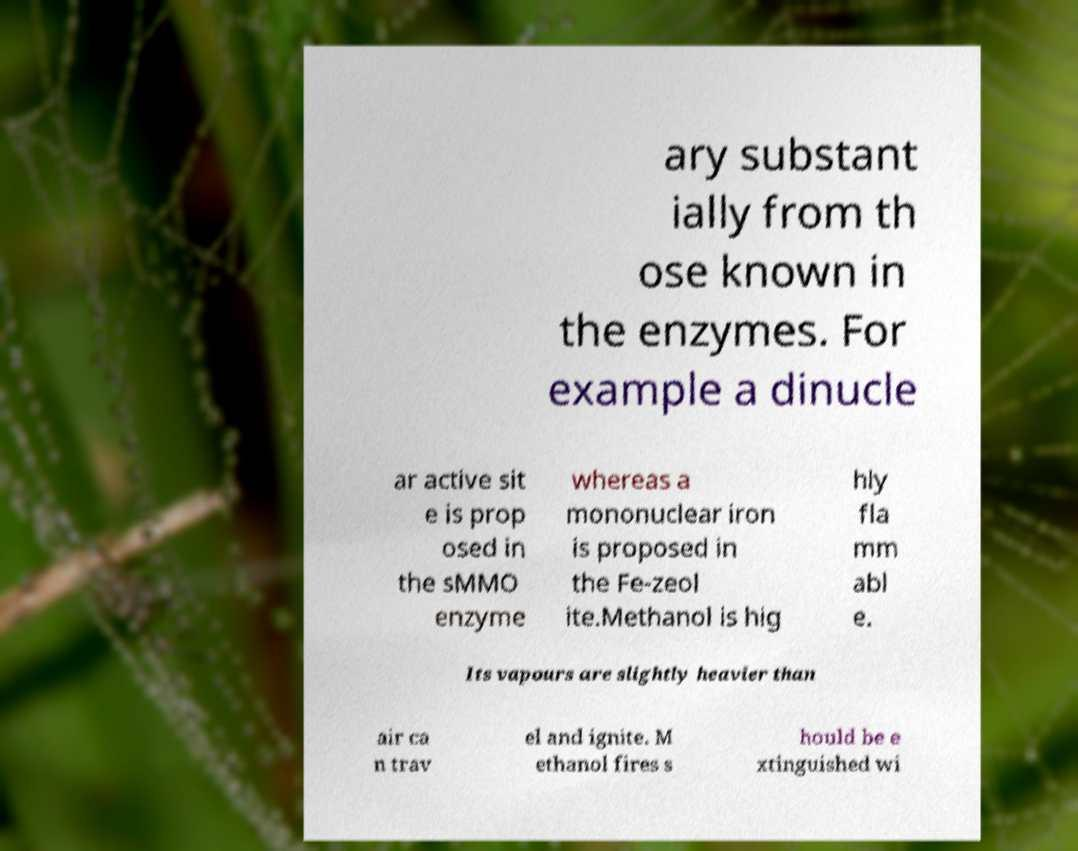For documentation purposes, I need the text within this image transcribed. Could you provide that? ary substant ially from th ose known in the enzymes. For example a dinucle ar active sit e is prop osed in the sMMO enzyme whereas a mononuclear iron is proposed in the Fe-zeol ite.Methanol is hig hly fla mm abl e. Its vapours are slightly heavier than air ca n trav el and ignite. M ethanol fires s hould be e xtinguished wi 